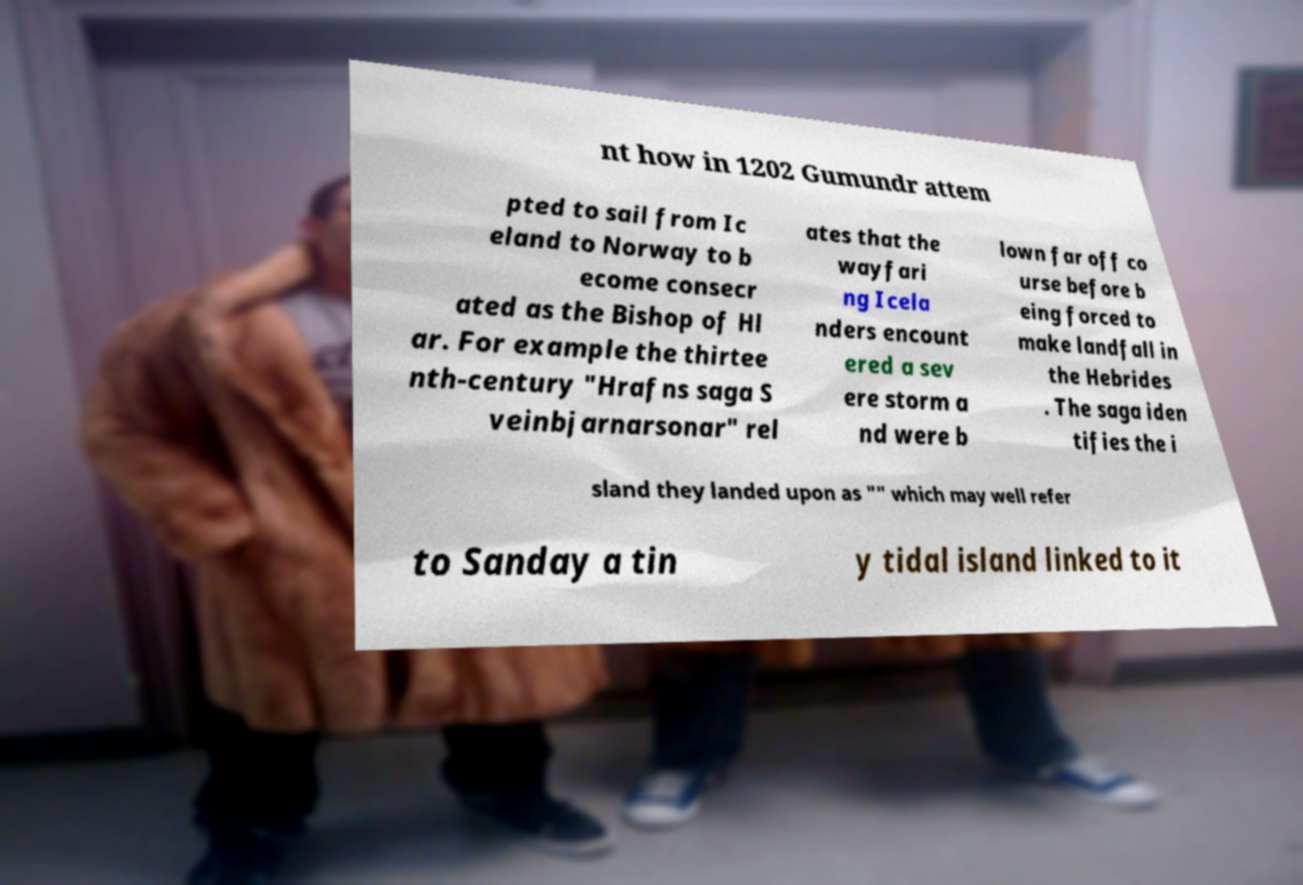For documentation purposes, I need the text within this image transcribed. Could you provide that? nt how in 1202 Gumundr attem pted to sail from Ic eland to Norway to b ecome consecr ated as the Bishop of Hl ar. For example the thirtee nth-century "Hrafns saga S veinbjarnarsonar" rel ates that the wayfari ng Icela nders encount ered a sev ere storm a nd were b lown far off co urse before b eing forced to make landfall in the Hebrides . The saga iden tifies the i sland they landed upon as "" which may well refer to Sanday a tin y tidal island linked to it 